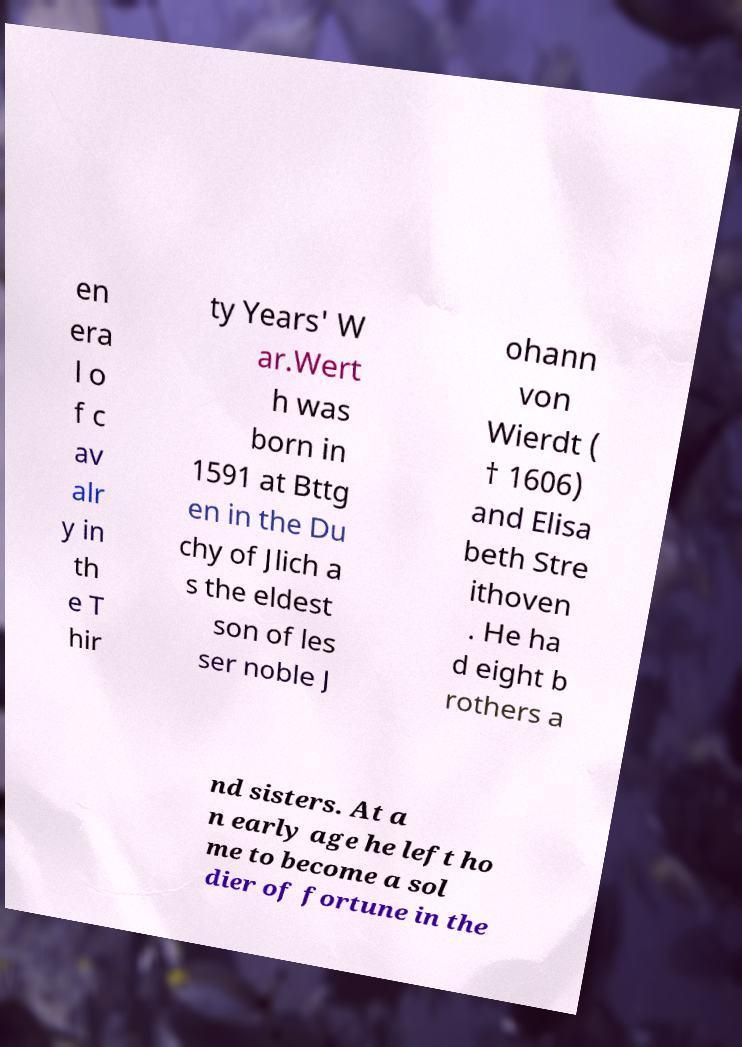There's text embedded in this image that I need extracted. Can you transcribe it verbatim? en era l o f c av alr y in th e T hir ty Years' W ar.Wert h was born in 1591 at Bttg en in the Du chy of Jlich a s the eldest son of les ser noble J ohann von Wierdt ( † 1606) and Elisa beth Stre ithoven . He ha d eight b rothers a nd sisters. At a n early age he left ho me to become a sol dier of fortune in the 